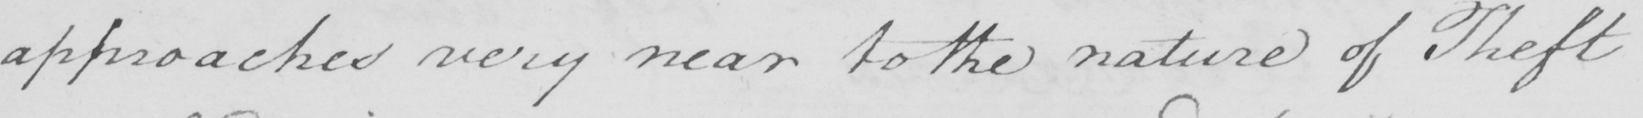Can you tell me what this handwritten text says? approaches very near to the nature of Theft 